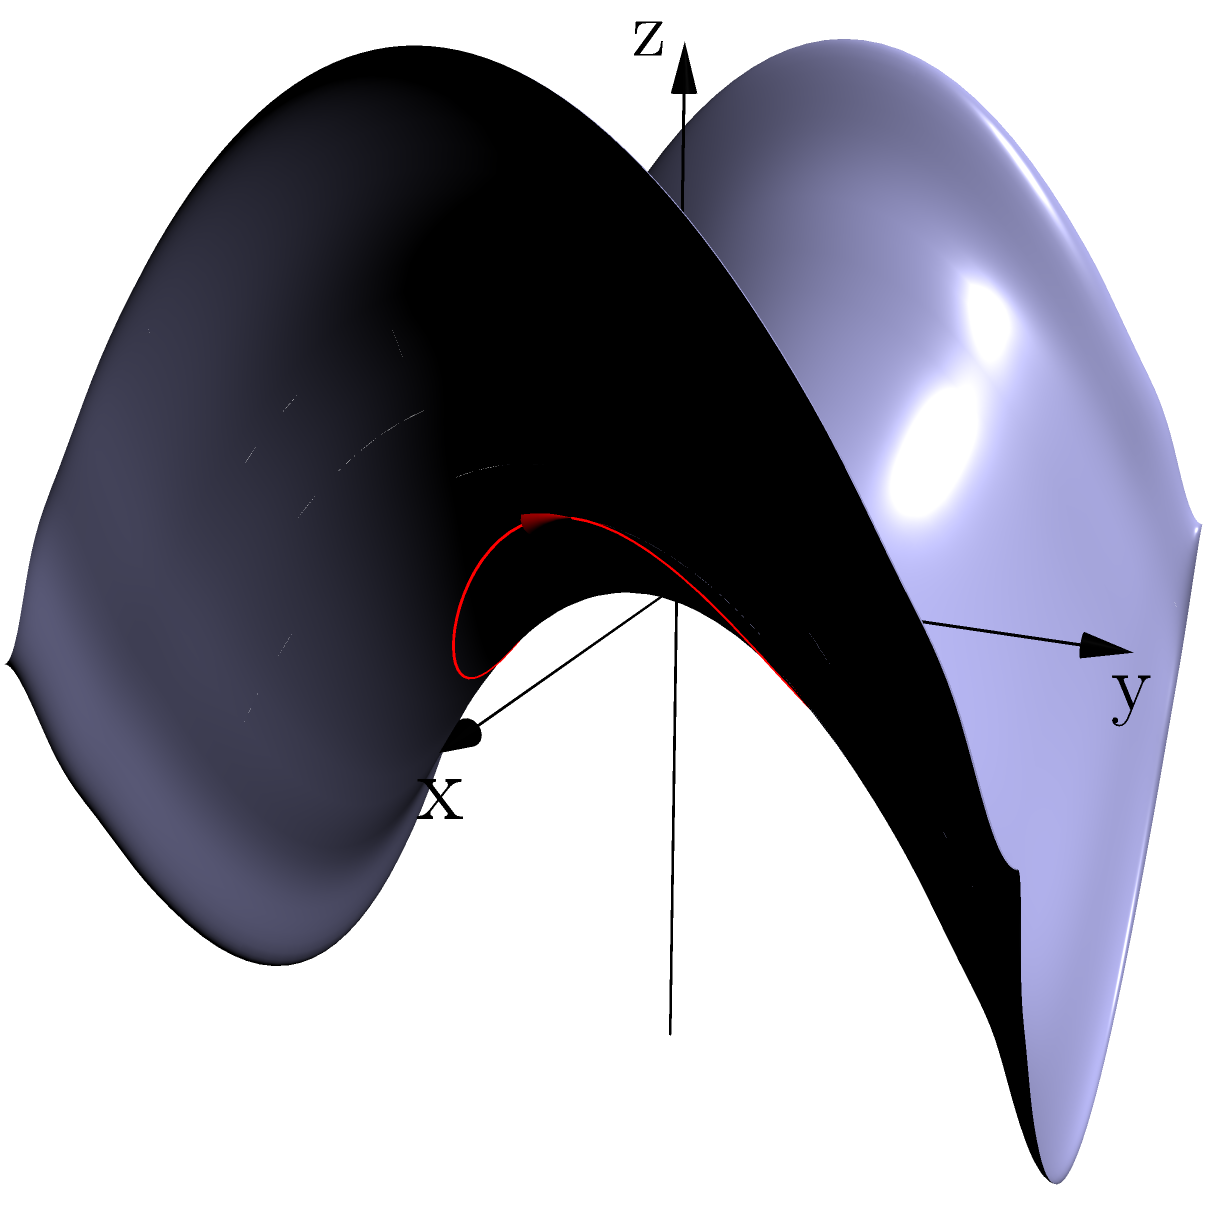In the context of ergonomic product design, consider a saddle-shaped surface represented by the equation $z = 0.5(x^2 - y^2)$. A geodesic path is drawn on this surface as shown in red. How might understanding this geodesic inform the design of a curved product surface for optimal user comfort and efficiency? To understand how this geodesic informs ergonomic product design, let's break it down step-by-step:

1. Surface shape: The equation $z = 0.5(x^2 - y^2)$ represents a saddle-shaped surface, which has both concave and convex curvatures.

2. Geodesic properties: A geodesic is the shortest path between two points on a curved surface. On this saddle surface, the geodesic follows a curved path that minimizes the distance traveled while conforming to the surface's shape.

3. Ergonomic implications:
   a) Natural movement: The geodesic represents the most natural and effortless path for a user's hand or body part to follow on this surface.
   b) Muscle strain reduction: Following this path requires minimal effort and reduces unnecessary muscle strain.
   c) Intuitive interaction: Users will naturally tend to move along these geodesic paths, making the product more intuitive to use.

4. Design applications:
   a) Contoured surfaces: The geodesic can guide the creation of contoured surfaces that match natural hand or body movements.
   b) Control placement: Interactive elements can be positioned along or near the geodesic for optimal reach and comfort.
   c) Visual cues: The product's visual design can subtly guide users along these ergonomic paths.

5. Efficiency considerations:
   a) Task optimization: Aligning frequently used features with geodesic paths can improve task efficiency.
   b) Reduced fatigue: By minimizing unnecessary movements, users can work for longer periods without discomfort.

6. Customization potential:
   a) User-specific geodesics: Different users may have slightly different optimal paths, allowing for personalized ergonomic designs.
   b) Adaptive surfaces: Future products could potentially adapt their shape to match individual users' optimal geodesics.

By incorporating an understanding of geodesics on curved surfaces, product designers can create more comfortable, efficient, and user-friendly products that naturally conform to human biomechanics and movement patterns.
Answer: Geodesics guide ergonomic contours, optimizing comfort and efficiency in product design. 